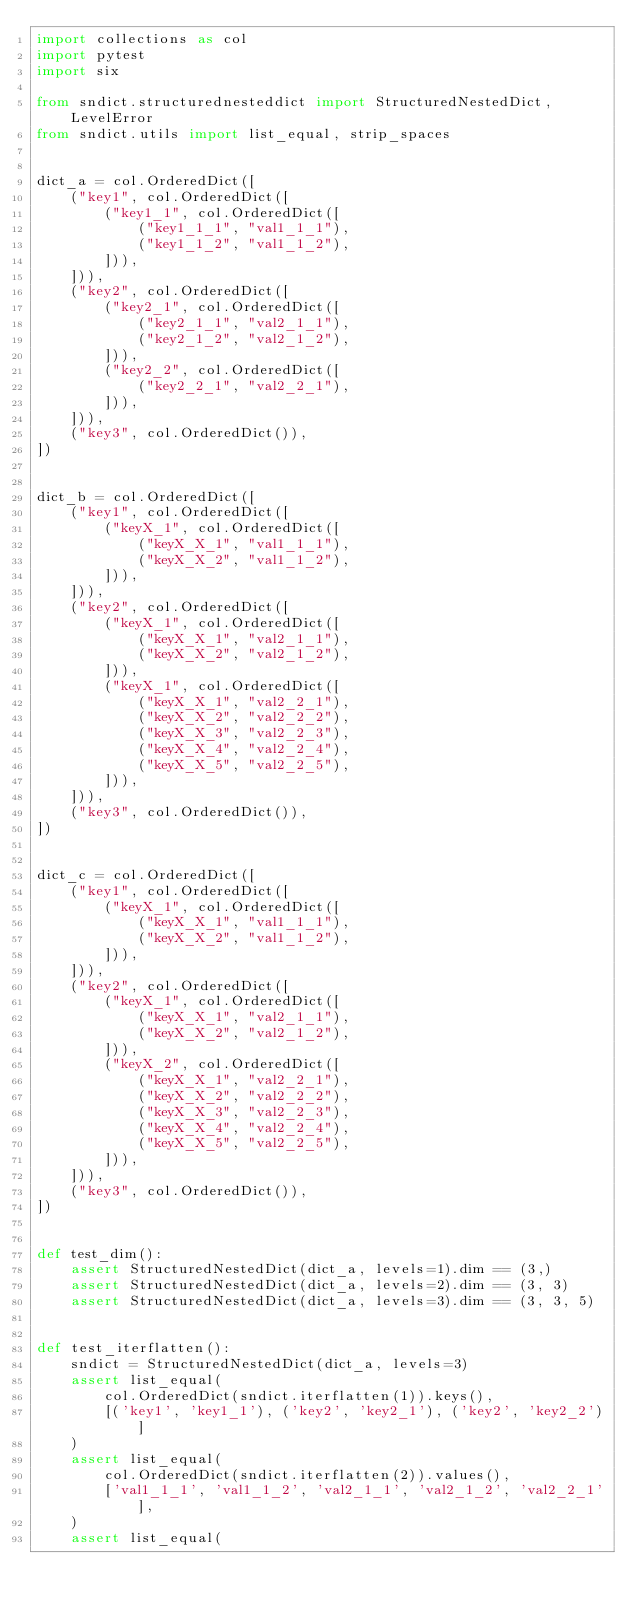Convert code to text. <code><loc_0><loc_0><loc_500><loc_500><_Python_>import collections as col
import pytest
import six

from sndict.structurednesteddict import StructuredNestedDict, LevelError
from sndict.utils import list_equal, strip_spaces


dict_a = col.OrderedDict([
    ("key1", col.OrderedDict([
        ("key1_1", col.OrderedDict([
            ("key1_1_1", "val1_1_1"),
            ("key1_1_2", "val1_1_2"),
        ])),
    ])),
    ("key2", col.OrderedDict([
        ("key2_1", col.OrderedDict([
            ("key2_1_1", "val2_1_1"),
            ("key2_1_2", "val2_1_2"),
        ])),
        ("key2_2", col.OrderedDict([
            ("key2_2_1", "val2_2_1"),
        ])),
    ])),
    ("key3", col.OrderedDict()),
])


dict_b = col.OrderedDict([
    ("key1", col.OrderedDict([
        ("keyX_1", col.OrderedDict([
            ("keyX_X_1", "val1_1_1"),
            ("keyX_X_2", "val1_1_2"),
        ])),
    ])),
    ("key2", col.OrderedDict([
        ("keyX_1", col.OrderedDict([
            ("keyX_X_1", "val2_1_1"),
            ("keyX_X_2", "val2_1_2"),
        ])),
        ("keyX_1", col.OrderedDict([
            ("keyX_X_1", "val2_2_1"),
            ("keyX_X_2", "val2_2_2"),
            ("keyX_X_3", "val2_2_3"),
            ("keyX_X_4", "val2_2_4"),
            ("keyX_X_5", "val2_2_5"),
        ])),
    ])),
    ("key3", col.OrderedDict()),
])


dict_c = col.OrderedDict([
    ("key1", col.OrderedDict([
        ("keyX_1", col.OrderedDict([
            ("keyX_X_1", "val1_1_1"),
            ("keyX_X_2", "val1_1_2"),
        ])),
    ])),
    ("key2", col.OrderedDict([
        ("keyX_1", col.OrderedDict([
            ("keyX_X_1", "val2_1_1"),
            ("keyX_X_2", "val2_1_2"),
        ])),
        ("keyX_2", col.OrderedDict([
            ("keyX_X_1", "val2_2_1"),
            ("keyX_X_2", "val2_2_2"),
            ("keyX_X_3", "val2_2_3"),
            ("keyX_X_4", "val2_2_4"),
            ("keyX_X_5", "val2_2_5"),
        ])),
    ])),
    ("key3", col.OrderedDict()),
])


def test_dim():
    assert StructuredNestedDict(dict_a, levels=1).dim == (3,)
    assert StructuredNestedDict(dict_a, levels=2).dim == (3, 3)
    assert StructuredNestedDict(dict_a, levels=3).dim == (3, 3, 5)


def test_iterflatten():
    sndict = StructuredNestedDict(dict_a, levels=3)
    assert list_equal(
        col.OrderedDict(sndict.iterflatten(1)).keys(),
        [('key1', 'key1_1'), ('key2', 'key2_1'), ('key2', 'key2_2')]
    )
    assert list_equal(
        col.OrderedDict(sndict.iterflatten(2)).values(),
        ['val1_1_1', 'val1_1_2', 'val2_1_1', 'val2_1_2', 'val2_2_1'],
    )
    assert list_equal(</code> 